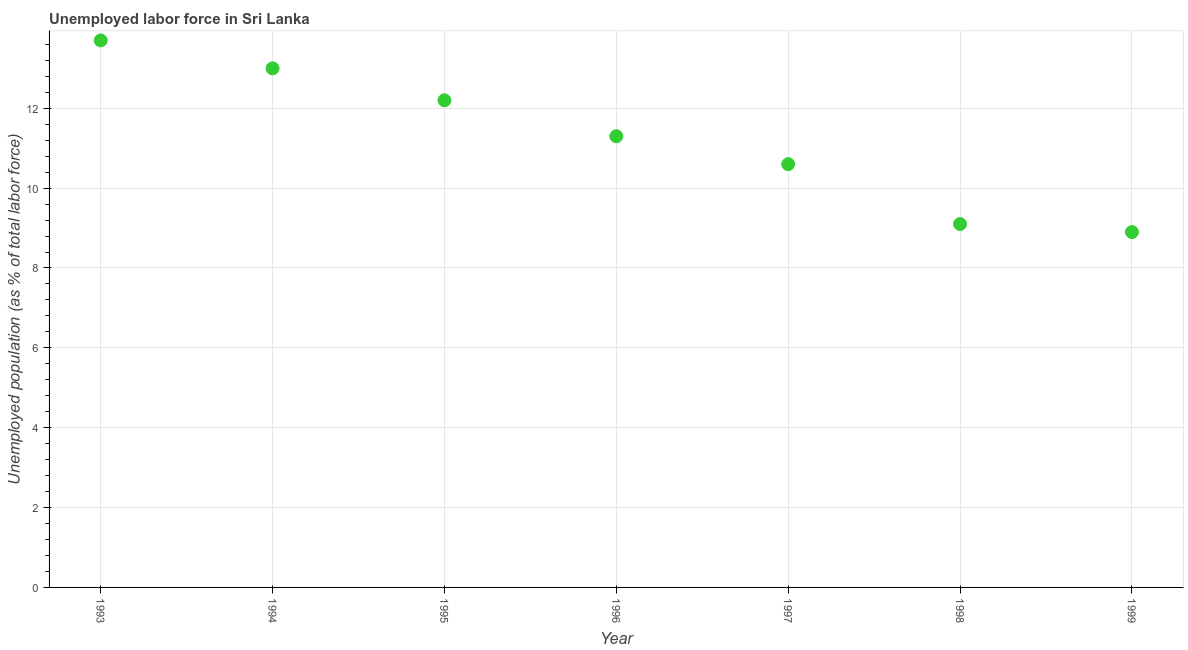Across all years, what is the maximum total unemployed population?
Provide a succinct answer. 13.7. Across all years, what is the minimum total unemployed population?
Your answer should be compact. 8.9. In which year was the total unemployed population maximum?
Your answer should be compact. 1993. In which year was the total unemployed population minimum?
Your answer should be compact. 1999. What is the sum of the total unemployed population?
Your answer should be compact. 78.8. What is the difference between the total unemployed population in 1993 and 1998?
Keep it short and to the point. 4.6. What is the average total unemployed population per year?
Offer a very short reply. 11.26. What is the median total unemployed population?
Give a very brief answer. 11.3. In how many years, is the total unemployed population greater than 1.2000000000000002 %?
Provide a succinct answer. 7. What is the ratio of the total unemployed population in 1993 to that in 1999?
Offer a terse response. 1.54. Is the total unemployed population in 1996 less than that in 1999?
Keep it short and to the point. No. Is the difference between the total unemployed population in 1994 and 1997 greater than the difference between any two years?
Ensure brevity in your answer.  No. What is the difference between the highest and the second highest total unemployed population?
Give a very brief answer. 0.7. Is the sum of the total unemployed population in 1995 and 1997 greater than the maximum total unemployed population across all years?
Keep it short and to the point. Yes. What is the difference between the highest and the lowest total unemployed population?
Ensure brevity in your answer.  4.8. How many years are there in the graph?
Give a very brief answer. 7. Are the values on the major ticks of Y-axis written in scientific E-notation?
Ensure brevity in your answer.  No. Does the graph contain any zero values?
Offer a terse response. No. What is the title of the graph?
Make the answer very short. Unemployed labor force in Sri Lanka. What is the label or title of the X-axis?
Offer a very short reply. Year. What is the label or title of the Y-axis?
Your answer should be compact. Unemployed population (as % of total labor force). What is the Unemployed population (as % of total labor force) in 1993?
Keep it short and to the point. 13.7. What is the Unemployed population (as % of total labor force) in 1995?
Provide a succinct answer. 12.2. What is the Unemployed population (as % of total labor force) in 1996?
Offer a terse response. 11.3. What is the Unemployed population (as % of total labor force) in 1997?
Keep it short and to the point. 10.6. What is the Unemployed population (as % of total labor force) in 1998?
Offer a terse response. 9.1. What is the Unemployed population (as % of total labor force) in 1999?
Keep it short and to the point. 8.9. What is the difference between the Unemployed population (as % of total labor force) in 1993 and 1994?
Ensure brevity in your answer.  0.7. What is the difference between the Unemployed population (as % of total labor force) in 1993 and 1995?
Offer a very short reply. 1.5. What is the difference between the Unemployed population (as % of total labor force) in 1993 and 1997?
Offer a very short reply. 3.1. What is the difference between the Unemployed population (as % of total labor force) in 1994 and 1995?
Ensure brevity in your answer.  0.8. What is the difference between the Unemployed population (as % of total labor force) in 1994 and 1996?
Ensure brevity in your answer.  1.7. What is the difference between the Unemployed population (as % of total labor force) in 1994 and 1998?
Ensure brevity in your answer.  3.9. What is the difference between the Unemployed population (as % of total labor force) in 1994 and 1999?
Offer a terse response. 4.1. What is the difference between the Unemployed population (as % of total labor force) in 1995 and 1996?
Give a very brief answer. 0.9. What is the difference between the Unemployed population (as % of total labor force) in 1995 and 1997?
Your answer should be compact. 1.6. What is the difference between the Unemployed population (as % of total labor force) in 1995 and 1998?
Your answer should be very brief. 3.1. What is the difference between the Unemployed population (as % of total labor force) in 1996 and 1997?
Ensure brevity in your answer.  0.7. What is the difference between the Unemployed population (as % of total labor force) in 1997 and 1998?
Your answer should be compact. 1.5. What is the difference between the Unemployed population (as % of total labor force) in 1997 and 1999?
Keep it short and to the point. 1.7. What is the difference between the Unemployed population (as % of total labor force) in 1998 and 1999?
Give a very brief answer. 0.2. What is the ratio of the Unemployed population (as % of total labor force) in 1993 to that in 1994?
Your response must be concise. 1.05. What is the ratio of the Unemployed population (as % of total labor force) in 1993 to that in 1995?
Your answer should be very brief. 1.12. What is the ratio of the Unemployed population (as % of total labor force) in 1993 to that in 1996?
Keep it short and to the point. 1.21. What is the ratio of the Unemployed population (as % of total labor force) in 1993 to that in 1997?
Offer a very short reply. 1.29. What is the ratio of the Unemployed population (as % of total labor force) in 1993 to that in 1998?
Provide a succinct answer. 1.5. What is the ratio of the Unemployed population (as % of total labor force) in 1993 to that in 1999?
Your response must be concise. 1.54. What is the ratio of the Unemployed population (as % of total labor force) in 1994 to that in 1995?
Your response must be concise. 1.07. What is the ratio of the Unemployed population (as % of total labor force) in 1994 to that in 1996?
Keep it short and to the point. 1.15. What is the ratio of the Unemployed population (as % of total labor force) in 1994 to that in 1997?
Ensure brevity in your answer.  1.23. What is the ratio of the Unemployed population (as % of total labor force) in 1994 to that in 1998?
Offer a very short reply. 1.43. What is the ratio of the Unemployed population (as % of total labor force) in 1994 to that in 1999?
Provide a short and direct response. 1.46. What is the ratio of the Unemployed population (as % of total labor force) in 1995 to that in 1996?
Make the answer very short. 1.08. What is the ratio of the Unemployed population (as % of total labor force) in 1995 to that in 1997?
Offer a very short reply. 1.15. What is the ratio of the Unemployed population (as % of total labor force) in 1995 to that in 1998?
Your response must be concise. 1.34. What is the ratio of the Unemployed population (as % of total labor force) in 1995 to that in 1999?
Provide a succinct answer. 1.37. What is the ratio of the Unemployed population (as % of total labor force) in 1996 to that in 1997?
Offer a terse response. 1.07. What is the ratio of the Unemployed population (as % of total labor force) in 1996 to that in 1998?
Keep it short and to the point. 1.24. What is the ratio of the Unemployed population (as % of total labor force) in 1996 to that in 1999?
Ensure brevity in your answer.  1.27. What is the ratio of the Unemployed population (as % of total labor force) in 1997 to that in 1998?
Ensure brevity in your answer.  1.17. What is the ratio of the Unemployed population (as % of total labor force) in 1997 to that in 1999?
Your answer should be compact. 1.19. What is the ratio of the Unemployed population (as % of total labor force) in 1998 to that in 1999?
Provide a short and direct response. 1.02. 